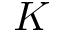<formula> <loc_0><loc_0><loc_500><loc_500>K</formula> 